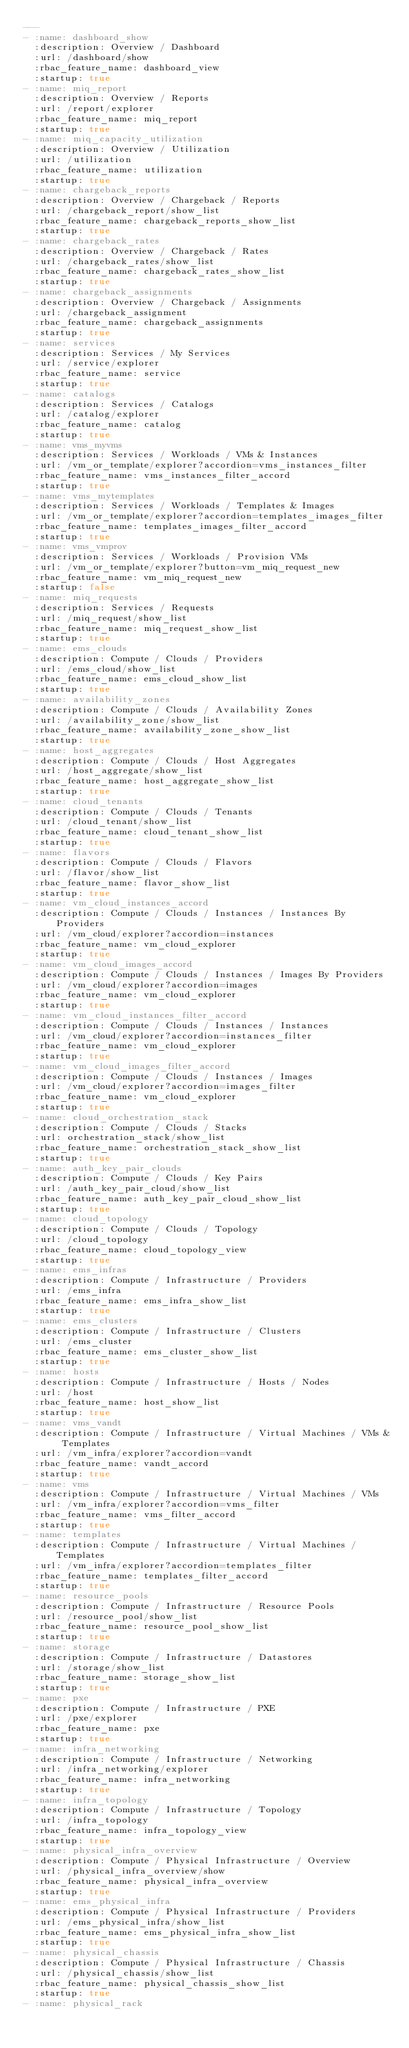<code> <loc_0><loc_0><loc_500><loc_500><_YAML_>---
- :name: dashboard_show
  :description: Overview / Dashboard
  :url: /dashboard/show
  :rbac_feature_name: dashboard_view
  :startup: true
- :name: miq_report
  :description: Overview / Reports
  :url: /report/explorer
  :rbac_feature_name: miq_report
  :startup: true
- :name: miq_capacity_utilization
  :description: Overview / Utilization
  :url: /utilization
  :rbac_feature_name: utilization
  :startup: true
- :name: chargeback_reports
  :description: Overview / Chargeback / Reports
  :url: /chargeback_report/show_list
  :rbac_feature_name: chargeback_reports_show_list
  :startup: true
- :name: chargeback_rates
  :description: Overview / Chargeback / Rates
  :url: /chargeback_rates/show_list
  :rbac_feature_name: chargeback_rates_show_list
  :startup: true
- :name: chargeback_assignments
  :description: Overview / Chargeback / Assignments
  :url: /chargeback_assignment
  :rbac_feature_name: chargeback_assignments
  :startup: true
- :name: services
  :description: Services / My Services
  :url: /service/explorer
  :rbac_feature_name: service
  :startup: true
- :name: catalogs
  :description: Services / Catalogs
  :url: /catalog/explorer
  :rbac_feature_name: catalog
  :startup: true
- :name: vms_myvms
  :description: Services / Workloads / VMs & Instances
  :url: /vm_or_template/explorer?accordion=vms_instances_filter
  :rbac_feature_name: vms_instances_filter_accord
  :startup: true
- :name: vms_mytemplates
  :description: Services / Workloads / Templates & Images
  :url: /vm_or_template/explorer?accordion=templates_images_filter
  :rbac_feature_name: templates_images_filter_accord
  :startup: true
- :name: vms_vmprov
  :description: Services / Workloads / Provision VMs
  :url: /vm_or_template/explorer?button=vm_miq_request_new
  :rbac_feature_name: vm_miq_request_new
  :startup: false
- :name: miq_requests
  :description: Services / Requests
  :url: /miq_request/show_list
  :rbac_feature_name: miq_request_show_list
  :startup: true
- :name: ems_clouds
  :description: Compute / Clouds / Providers
  :url: /ems_cloud/show_list
  :rbac_feature_name: ems_cloud_show_list
  :startup: true
- :name: availability_zones
  :description: Compute / Clouds / Availability Zones
  :url: /availability_zone/show_list
  :rbac_feature_name: availability_zone_show_list
  :startup: true
- :name: host_aggregates
  :description: Compute / Clouds / Host Aggregates
  :url: /host_aggregate/show_list
  :rbac_feature_name: host_aggregate_show_list
  :startup: true
- :name: cloud_tenants
  :description: Compute / Clouds / Tenants
  :url: /cloud_tenant/show_list
  :rbac_feature_name: cloud_tenant_show_list
  :startup: true
- :name: flavors
  :description: Compute / Clouds / Flavors
  :url: /flavor/show_list
  :rbac_feature_name: flavor_show_list
  :startup: true
- :name: vm_cloud_instances_accord
  :description: Compute / Clouds / Instances / Instances By Providers
  :url: /vm_cloud/explorer?accordion=instances
  :rbac_feature_name: vm_cloud_explorer
  :startup: true
- :name: vm_cloud_images_accord
  :description: Compute / Clouds / Instances / Images By Providers
  :url: /vm_cloud/explorer?accordion=images
  :rbac_feature_name: vm_cloud_explorer
  :startup: true
- :name: vm_cloud_instances_filter_accord
  :description: Compute / Clouds / Instances / Instances
  :url: /vm_cloud/explorer?accordion=instances_filter
  :rbac_feature_name: vm_cloud_explorer
  :startup: true
- :name: vm_cloud_images_filter_accord
  :description: Compute / Clouds / Instances / Images
  :url: /vm_cloud/explorer?accordion=images_filter
  :rbac_feature_name: vm_cloud_explorer
  :startup: true
- :name: cloud_orchestration_stack
  :description: Compute / Clouds / Stacks
  :url: orchestration_stack/show_list
  :rbac_feature_name: orchestration_stack_show_list
  :startup: true
- :name: auth_key_pair_clouds
  :description: Compute / Clouds / Key Pairs
  :url: /auth_key_pair_cloud/show_list
  :rbac_feature_name: auth_key_pair_cloud_show_list
  :startup: true
- :name: cloud_topology
  :description: Compute / Clouds / Topology
  :url: /cloud_topology
  :rbac_feature_name: cloud_topology_view
  :startup: true
- :name: ems_infras
  :description: Compute / Infrastructure / Providers
  :url: /ems_infra
  :rbac_feature_name: ems_infra_show_list
  :startup: true
- :name: ems_clusters
  :description: Compute / Infrastructure / Clusters
  :url: /ems_cluster
  :rbac_feature_name: ems_cluster_show_list
  :startup: true
- :name: hosts
  :description: Compute / Infrastructure / Hosts / Nodes
  :url: /host
  :rbac_feature_name: host_show_list
  :startup: true
- :name: vms_vandt
  :description: Compute / Infrastructure / Virtual Machines / VMs & Templates
  :url: /vm_infra/explorer?accordion=vandt
  :rbac_feature_name: vandt_accord
  :startup: true
- :name: vms
  :description: Compute / Infrastructure / Virtual Machines / VMs
  :url: /vm_infra/explorer?accordion=vms_filter
  :rbac_feature_name: vms_filter_accord
  :startup: true
- :name: templates
  :description: Compute / Infrastructure / Virtual Machines / Templates
  :url: /vm_infra/explorer?accordion=templates_filter
  :rbac_feature_name: templates_filter_accord
  :startup: true
- :name: resource_pools
  :description: Compute / Infrastructure / Resource Pools
  :url: /resource_pool/show_list
  :rbac_feature_name: resource_pool_show_list
  :startup: true
- :name: storage
  :description: Compute / Infrastructure / Datastores
  :url: /storage/show_list
  :rbac_feature_name: storage_show_list
  :startup: true
- :name: pxe
  :description: Compute / Infrastructure / PXE
  :url: /pxe/explorer
  :rbac_feature_name: pxe
  :startup: true
- :name: infra_networking
  :description: Compute / Infrastructure / Networking
  :url: /infra_networking/explorer
  :rbac_feature_name: infra_networking
  :startup: true
- :name: infra_topology
  :description: Compute / Infrastructure / Topology
  :url: /infra_topology
  :rbac_feature_name: infra_topology_view
  :startup: true
- :name: physical_infra_overview
  :description: Compute / Physical Infrastructure / Overview
  :url: /physical_infra_overview/show
  :rbac_feature_name: physical_infra_overview
  :startup: true
- :name: ems_physical_infra
  :description: Compute / Physical Infrastructure / Providers
  :url: /ems_physical_infra/show_list
  :rbac_feature_name: ems_physical_infra_show_list
  :startup: true
- :name: physical_chassis
  :description: Compute / Physical Infrastructure / Chassis
  :url: /physical_chassis/show_list
  :rbac_feature_name: physical_chassis_show_list
  :startup: true
- :name: physical_rack</code> 